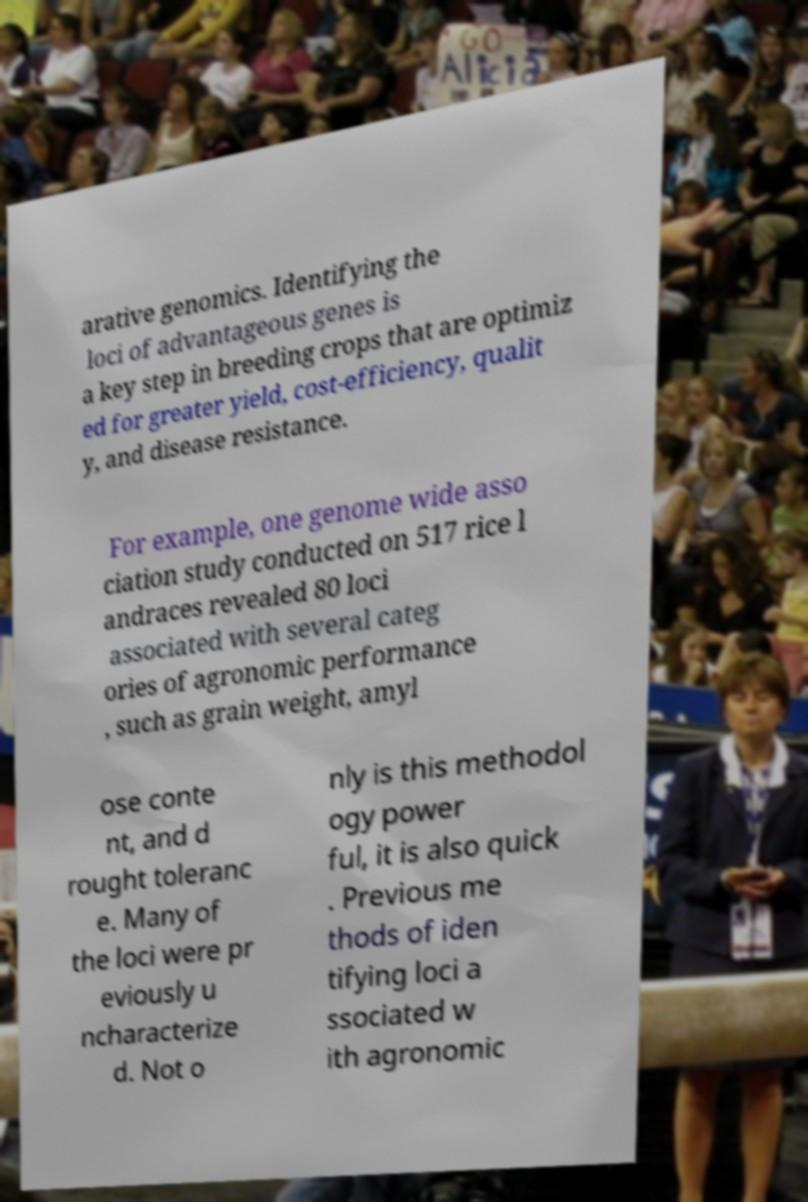For documentation purposes, I need the text within this image transcribed. Could you provide that? arative genomics. Identifying the loci of advantageous genes is a key step in breeding crops that are optimiz ed for greater yield, cost-efficiency, qualit y, and disease resistance. For example, one genome wide asso ciation study conducted on 517 rice l andraces revealed 80 loci associated with several categ ories of agronomic performance , such as grain weight, amyl ose conte nt, and d rought toleranc e. Many of the loci were pr eviously u ncharacterize d. Not o nly is this methodol ogy power ful, it is also quick . Previous me thods of iden tifying loci a ssociated w ith agronomic 